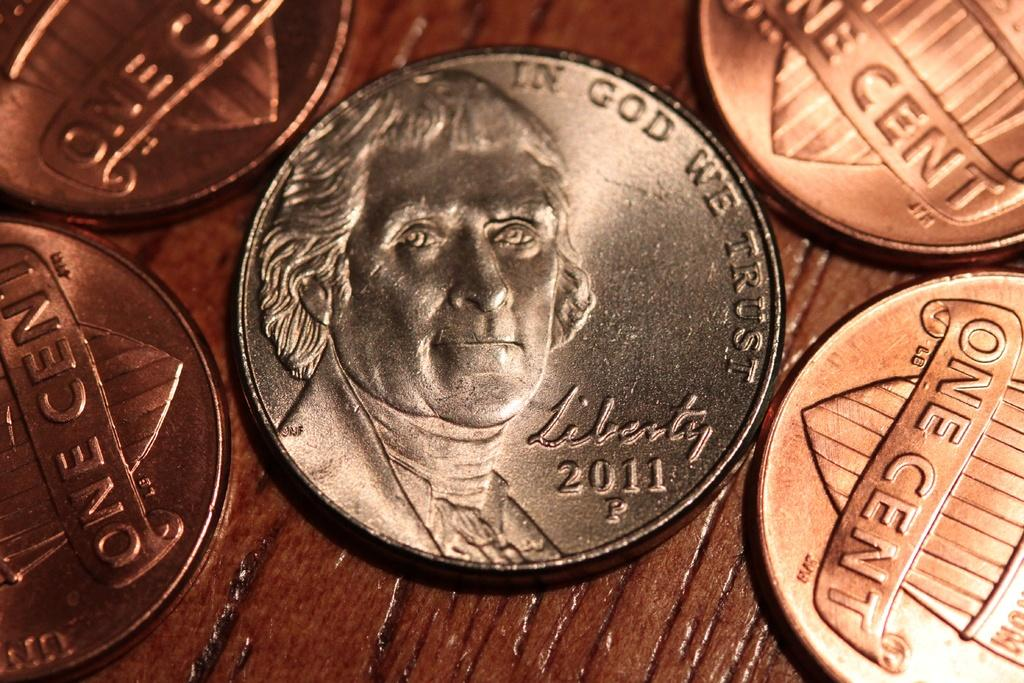Provide a one-sentence caption for the provided image. FOUR SHINY NEW PENNIES AND A 2011 NICKEL. 